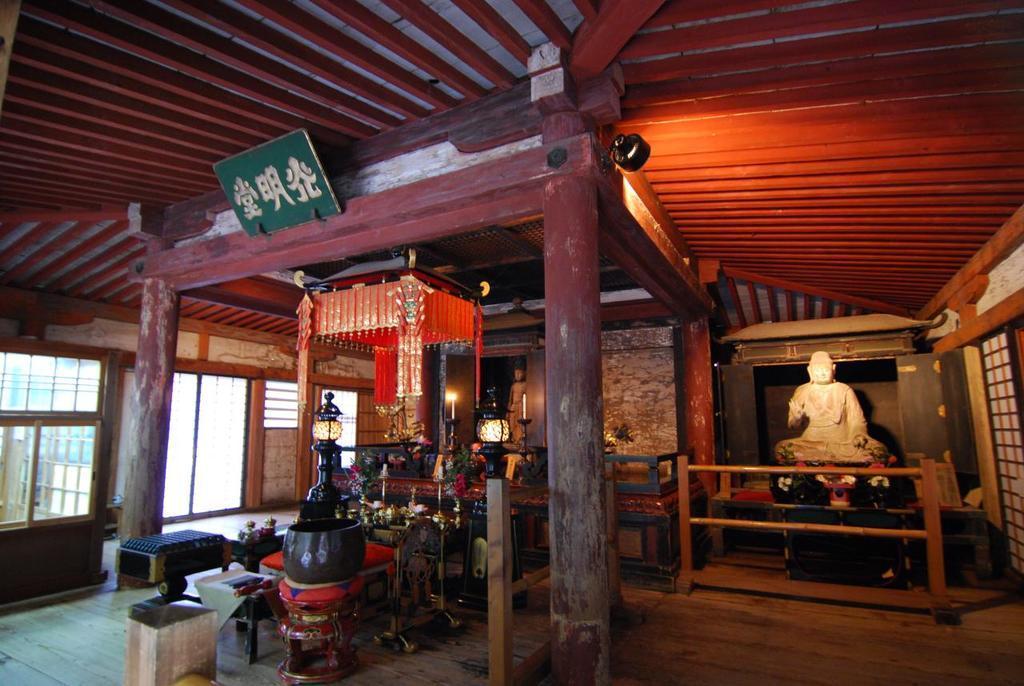In one or two sentences, can you explain what this image depicts? In this picture we can see pillars,statues,roof and some objects. 